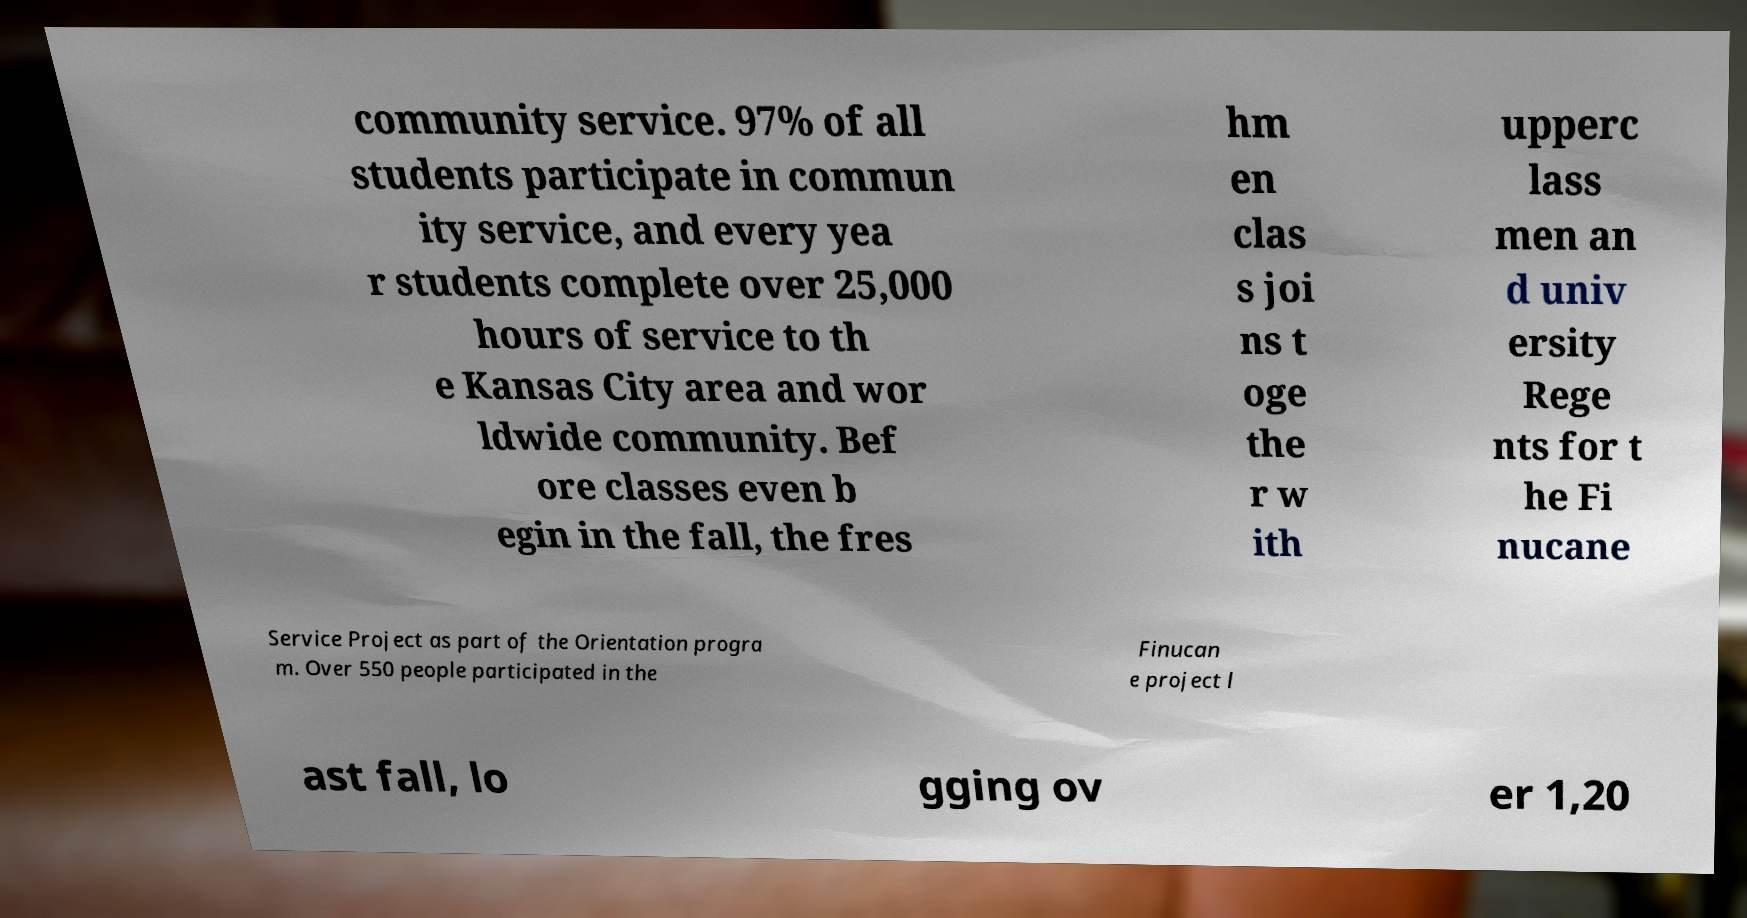Please identify and transcribe the text found in this image. community service. 97% of all students participate in commun ity service, and every yea r students complete over 25,000 hours of service to th e Kansas City area and wor ldwide community. Bef ore classes even b egin in the fall, the fres hm en clas s joi ns t oge the r w ith upperc lass men an d univ ersity Rege nts for t he Fi nucane Service Project as part of the Orientation progra m. Over 550 people participated in the Finucan e project l ast fall, lo gging ov er 1,20 